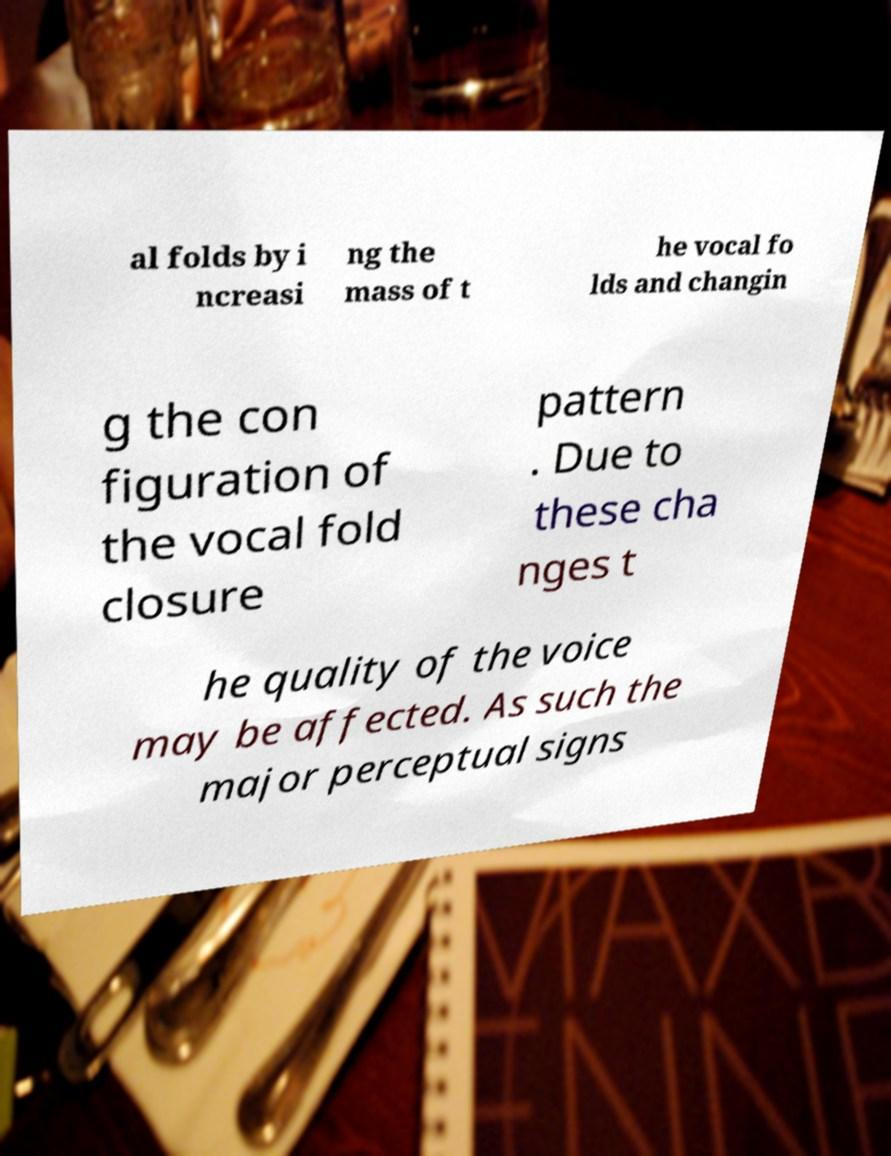Please read and relay the text visible in this image. What does it say? al folds by i ncreasi ng the mass of t he vocal fo lds and changin g the con figuration of the vocal fold closure pattern . Due to these cha nges t he quality of the voice may be affected. As such the major perceptual signs 